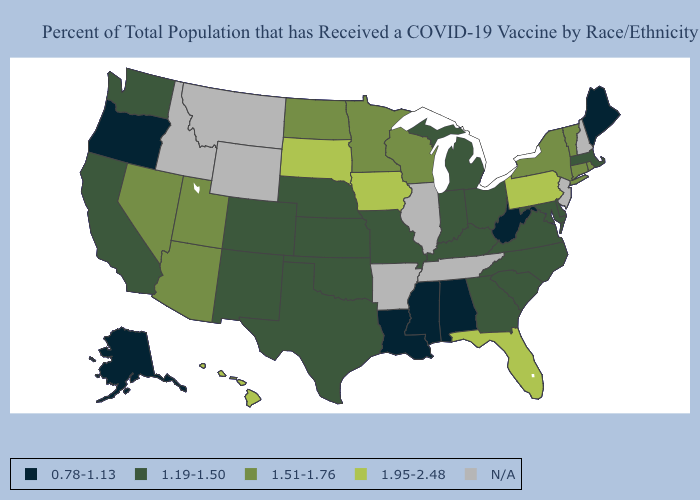What is the value of Georgia?
Answer briefly. 1.19-1.50. Does Virginia have the highest value in the South?
Short answer required. No. What is the value of Louisiana?
Give a very brief answer. 0.78-1.13. What is the value of Hawaii?
Be succinct. 1.95-2.48. What is the lowest value in states that border Louisiana?
Keep it brief. 0.78-1.13. What is the value of Vermont?
Answer briefly. 1.51-1.76. What is the lowest value in the USA?
Answer briefly. 0.78-1.13. Name the states that have a value in the range 1.95-2.48?
Short answer required. Florida, Hawaii, Iowa, Pennsylvania, South Dakota. What is the value of California?
Be succinct. 1.19-1.50. Is the legend a continuous bar?
Quick response, please. No. Does the first symbol in the legend represent the smallest category?
Keep it brief. Yes. Which states have the lowest value in the Northeast?
Write a very short answer. Maine. Name the states that have a value in the range 1.19-1.50?
Be succinct. California, Colorado, Delaware, Georgia, Indiana, Kansas, Kentucky, Maryland, Massachusetts, Michigan, Missouri, Nebraska, New Mexico, North Carolina, Ohio, Oklahoma, South Carolina, Texas, Virginia, Washington. Does Mississippi have the lowest value in the South?
Answer briefly. Yes. How many symbols are there in the legend?
Short answer required. 5. 